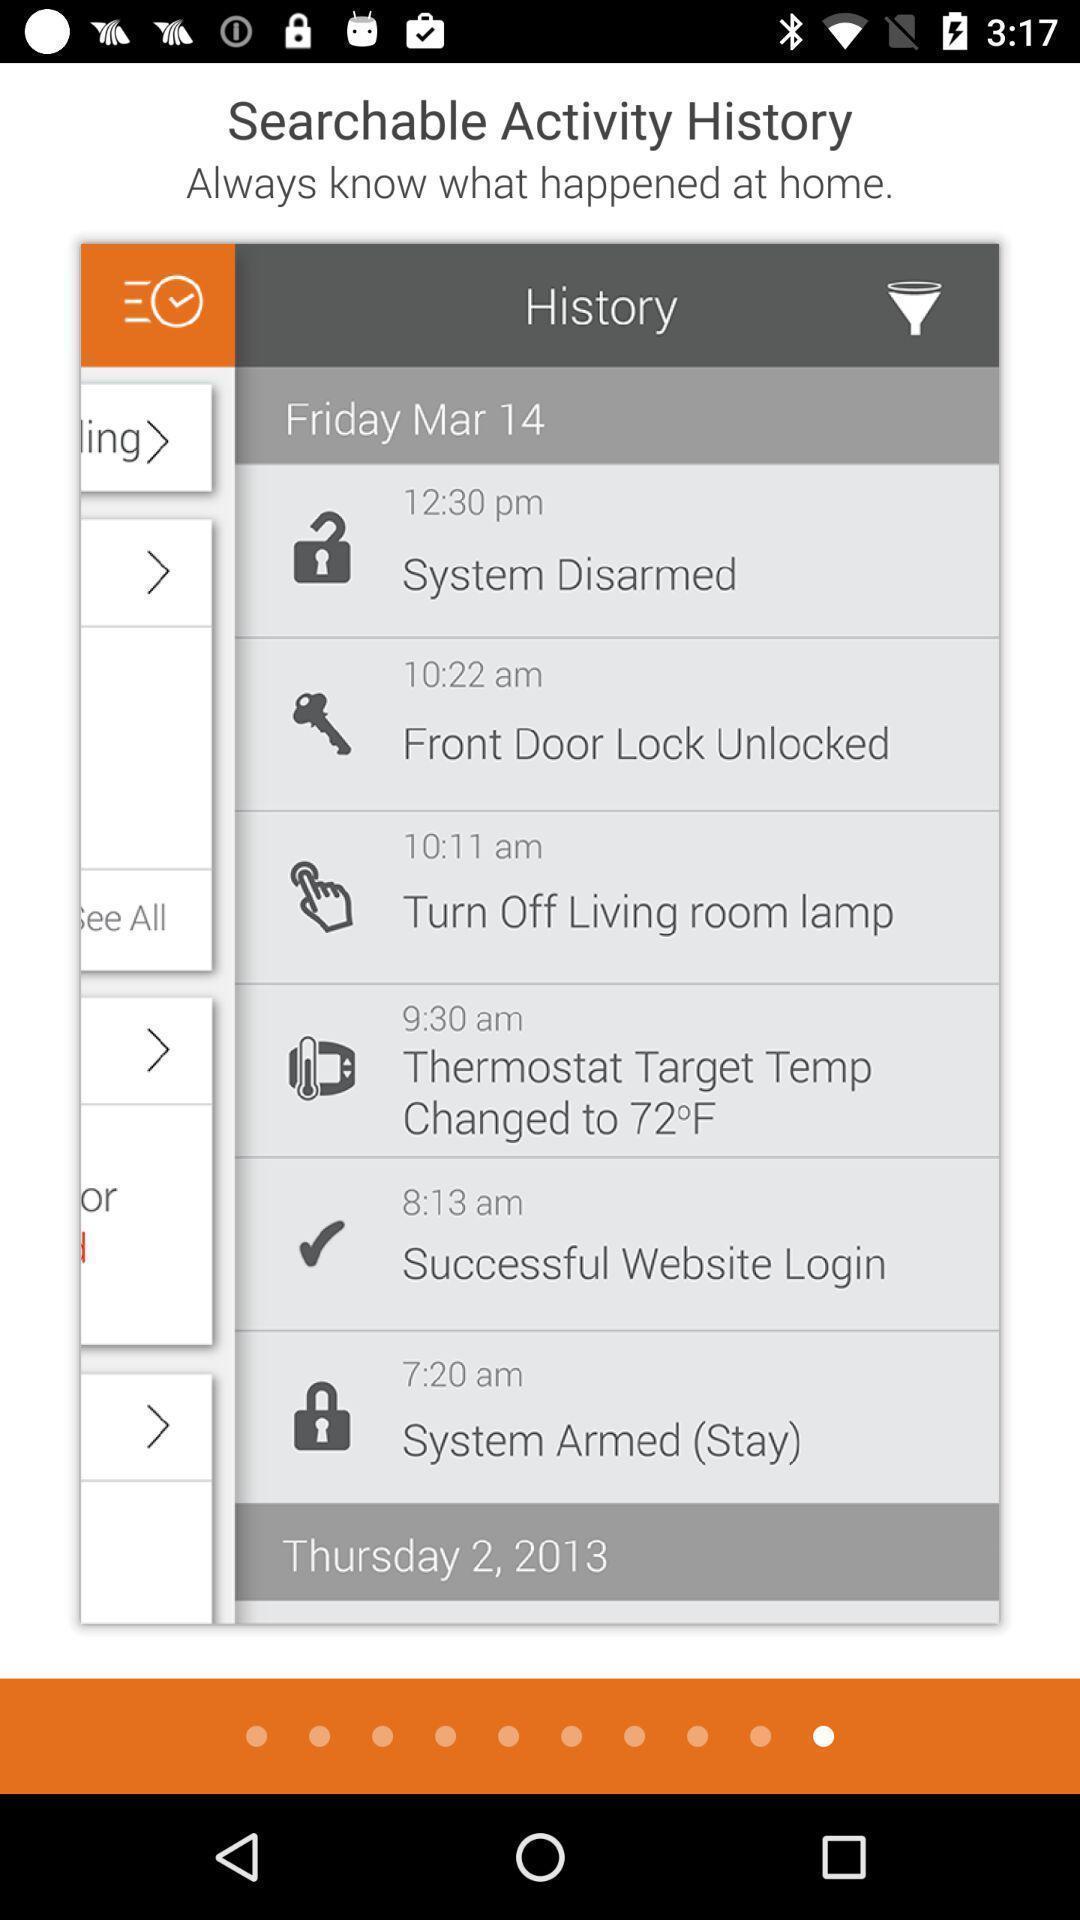Give me a summary of this screen capture. Screen displaying the instructions to use an app. 